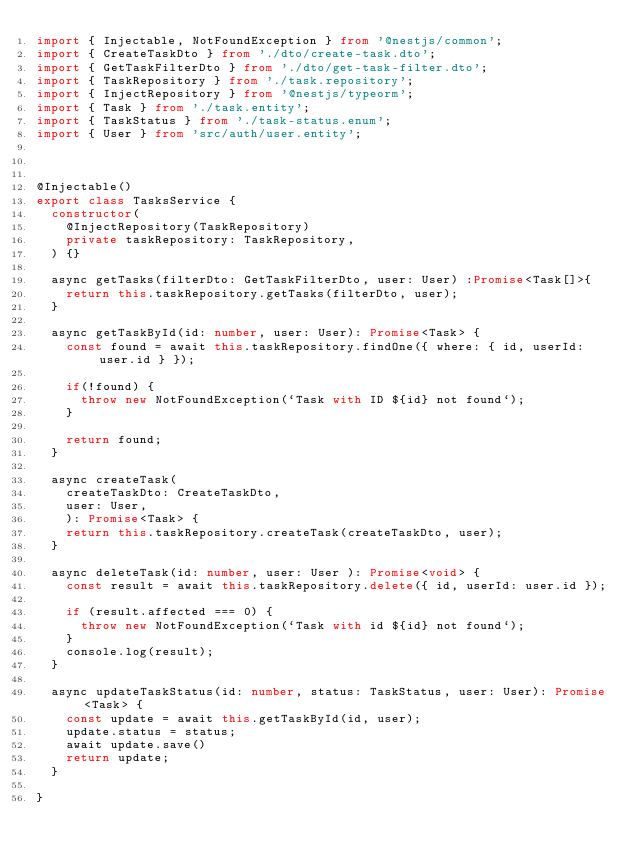Convert code to text. <code><loc_0><loc_0><loc_500><loc_500><_TypeScript_>import { Injectable, NotFoundException } from '@nestjs/common';
import { CreateTaskDto } from './dto/create-task.dto';
import { GetTaskFilterDto } from './dto/get-task-filter.dto';
import { TaskRepository } from './task.repository';
import { InjectRepository } from '@nestjs/typeorm';
import { Task } from './task.entity';
import { TaskStatus } from './task-status.enum';
import { User } from 'src/auth/user.entity';



@Injectable()
export class TasksService {
  constructor(
    @InjectRepository(TaskRepository)
    private taskRepository: TaskRepository,
  ) {}

  async getTasks(filterDto: GetTaskFilterDto, user: User) :Promise<Task[]>{
    return this.taskRepository.getTasks(filterDto, user);
  }

  async getTaskById(id: number, user: User): Promise<Task> {
    const found = await this.taskRepository.findOne({ where: { id, userId: user.id } });

    if(!found) {
      throw new NotFoundException(`Task with ID ${id} not found`);
    }

    return found;
  }

  async createTask(
    createTaskDto: CreateTaskDto,
    user: User,
    ): Promise<Task> {
    return this.taskRepository.createTask(createTaskDto, user);
  }

  async deleteTask(id: number, user: User ): Promise<void> {
    const result = await this.taskRepository.delete({ id, userId: user.id });

    if (result.affected === 0) {
      throw new NotFoundException(`Task with id ${id} not found`);
    }
    console.log(result);
  }

  async updateTaskStatus(id: number, status: TaskStatus, user: User): Promise<Task> {
    const update = await this.getTaskById(id, user);
    update.status = status;
    await update.save()
    return update;
  }
  
}
</code> 